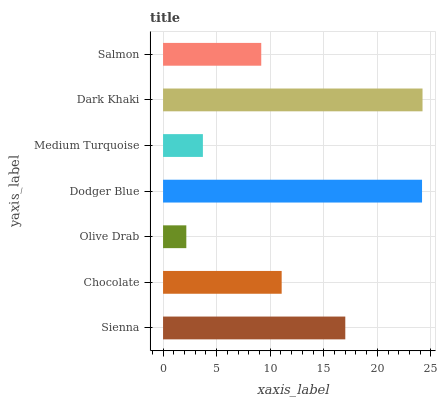Is Olive Drab the minimum?
Answer yes or no. Yes. Is Dark Khaki the maximum?
Answer yes or no. Yes. Is Chocolate the minimum?
Answer yes or no. No. Is Chocolate the maximum?
Answer yes or no. No. Is Sienna greater than Chocolate?
Answer yes or no. Yes. Is Chocolate less than Sienna?
Answer yes or no. Yes. Is Chocolate greater than Sienna?
Answer yes or no. No. Is Sienna less than Chocolate?
Answer yes or no. No. Is Chocolate the high median?
Answer yes or no. Yes. Is Chocolate the low median?
Answer yes or no. Yes. Is Salmon the high median?
Answer yes or no. No. Is Dark Khaki the low median?
Answer yes or no. No. 